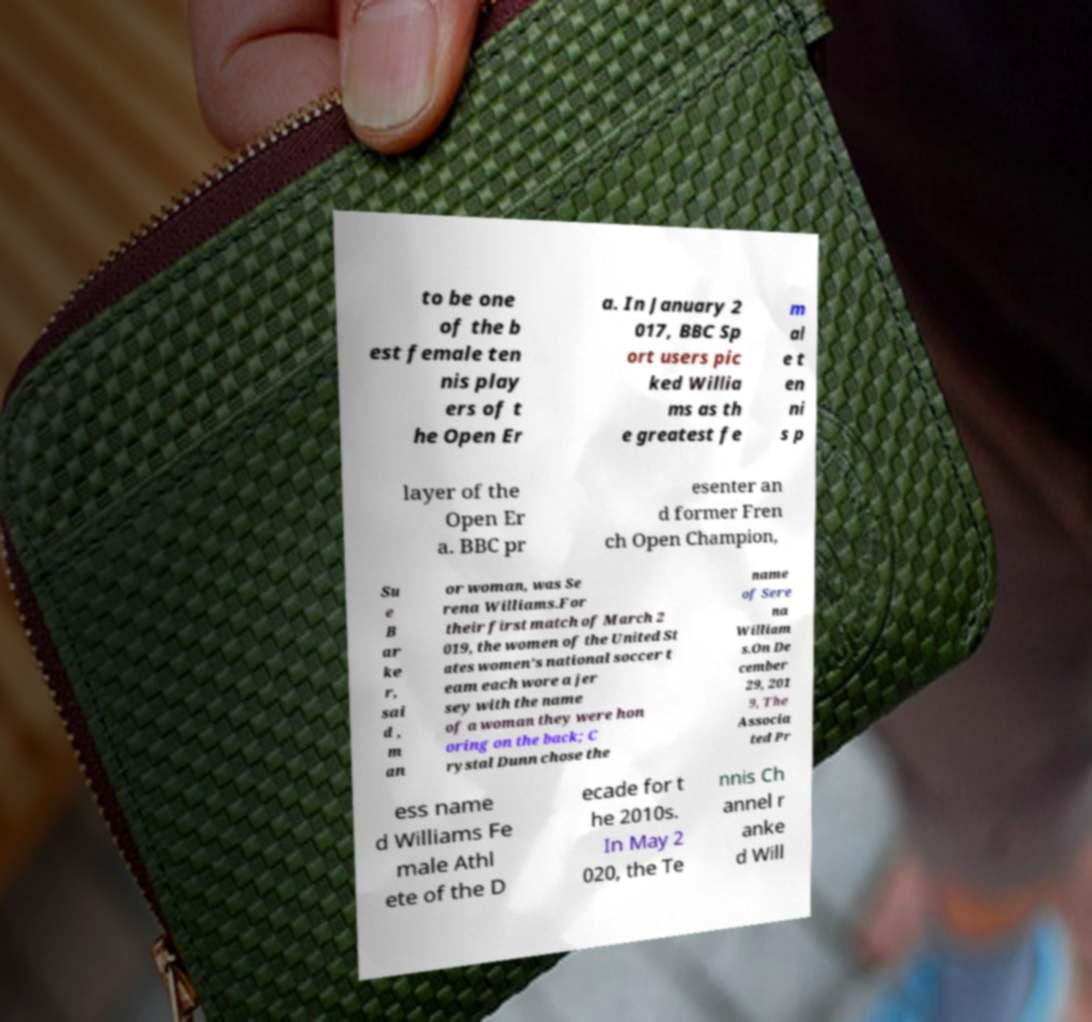What messages or text are displayed in this image? I need them in a readable, typed format. to be one of the b est female ten nis play ers of t he Open Er a. In January 2 017, BBC Sp ort users pic ked Willia ms as th e greatest fe m al e t en ni s p layer of the Open Er a. BBC pr esenter an d former Fren ch Open Champion, Su e B ar ke r, sai d , m an or woman, was Se rena Williams.For their first match of March 2 019, the women of the United St ates women's national soccer t eam each wore a jer sey with the name of a woman they were hon oring on the back; C rystal Dunn chose the name of Sere na William s.On De cember 29, 201 9, The Associa ted Pr ess name d Williams Fe male Athl ete of the D ecade for t he 2010s. In May 2 020, the Te nnis Ch annel r anke d Will 